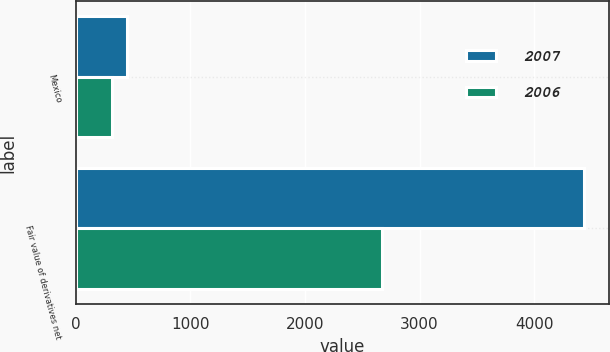Convert chart. <chart><loc_0><loc_0><loc_500><loc_500><stacked_bar_chart><ecel><fcel>Mexico<fcel>Fair value of derivatives net<nl><fcel>2007<fcel>451<fcel>4432<nl><fcel>2006<fcel>316<fcel>2670<nl></chart> 